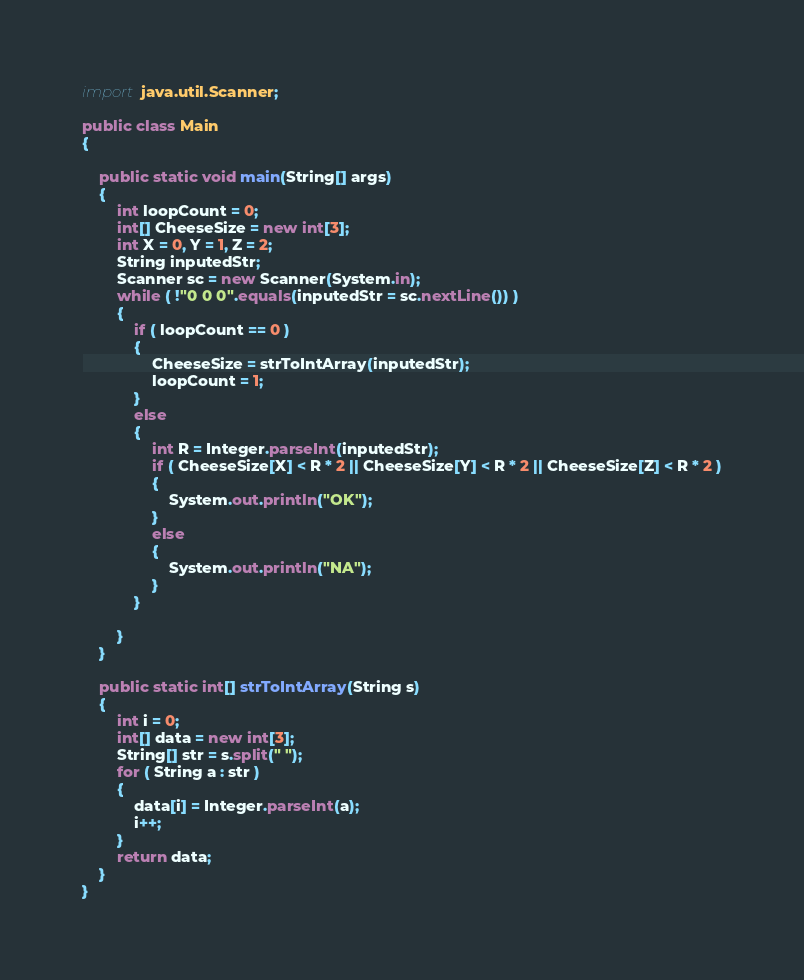<code> <loc_0><loc_0><loc_500><loc_500><_Java_>
import java.util.Scanner;

public class Main
{

    public static void main(String[] args)
    {
        int loopCount = 0;
        int[] CheeseSize = new int[3];
        int X = 0, Y = 1, Z = 2;
        String inputedStr;
        Scanner sc = new Scanner(System.in);
        while ( !"0 0 0".equals(inputedStr = sc.nextLine()) )
        {
            if ( loopCount == 0 )
            {
                CheeseSize = strToIntArray(inputedStr);
                loopCount = 1;
            }
            else
            {
                int R = Integer.parseInt(inputedStr);
                if ( CheeseSize[X] < R * 2 || CheeseSize[Y] < R * 2 || CheeseSize[Z] < R * 2 )
                {
                    System.out.println("OK");
                }
                else
                {
                    System.out.println("NA");
                }
            }

        }
    }

    public static int[] strToIntArray(String s)
    {
        int i = 0;
        int[] data = new int[3];
        String[] str = s.split(" ");
        for ( String a : str )
        {
            data[i] = Integer.parseInt(a);
            i++;
        }
        return data;
    }
}</code> 